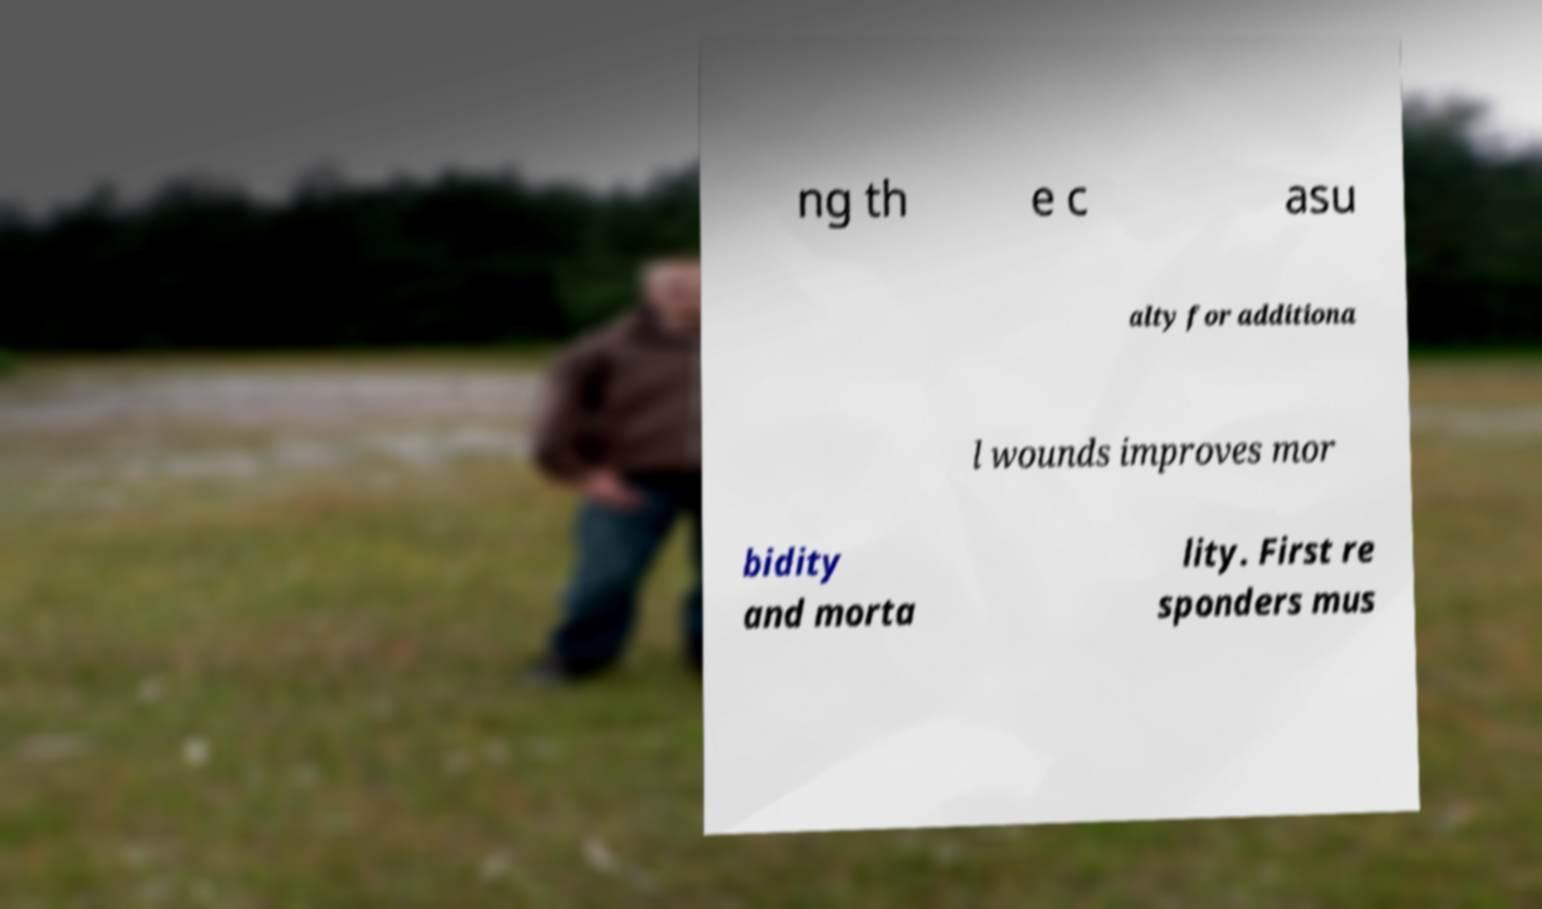Please identify and transcribe the text found in this image. ng th e c asu alty for additiona l wounds improves mor bidity and morta lity. First re sponders mus 